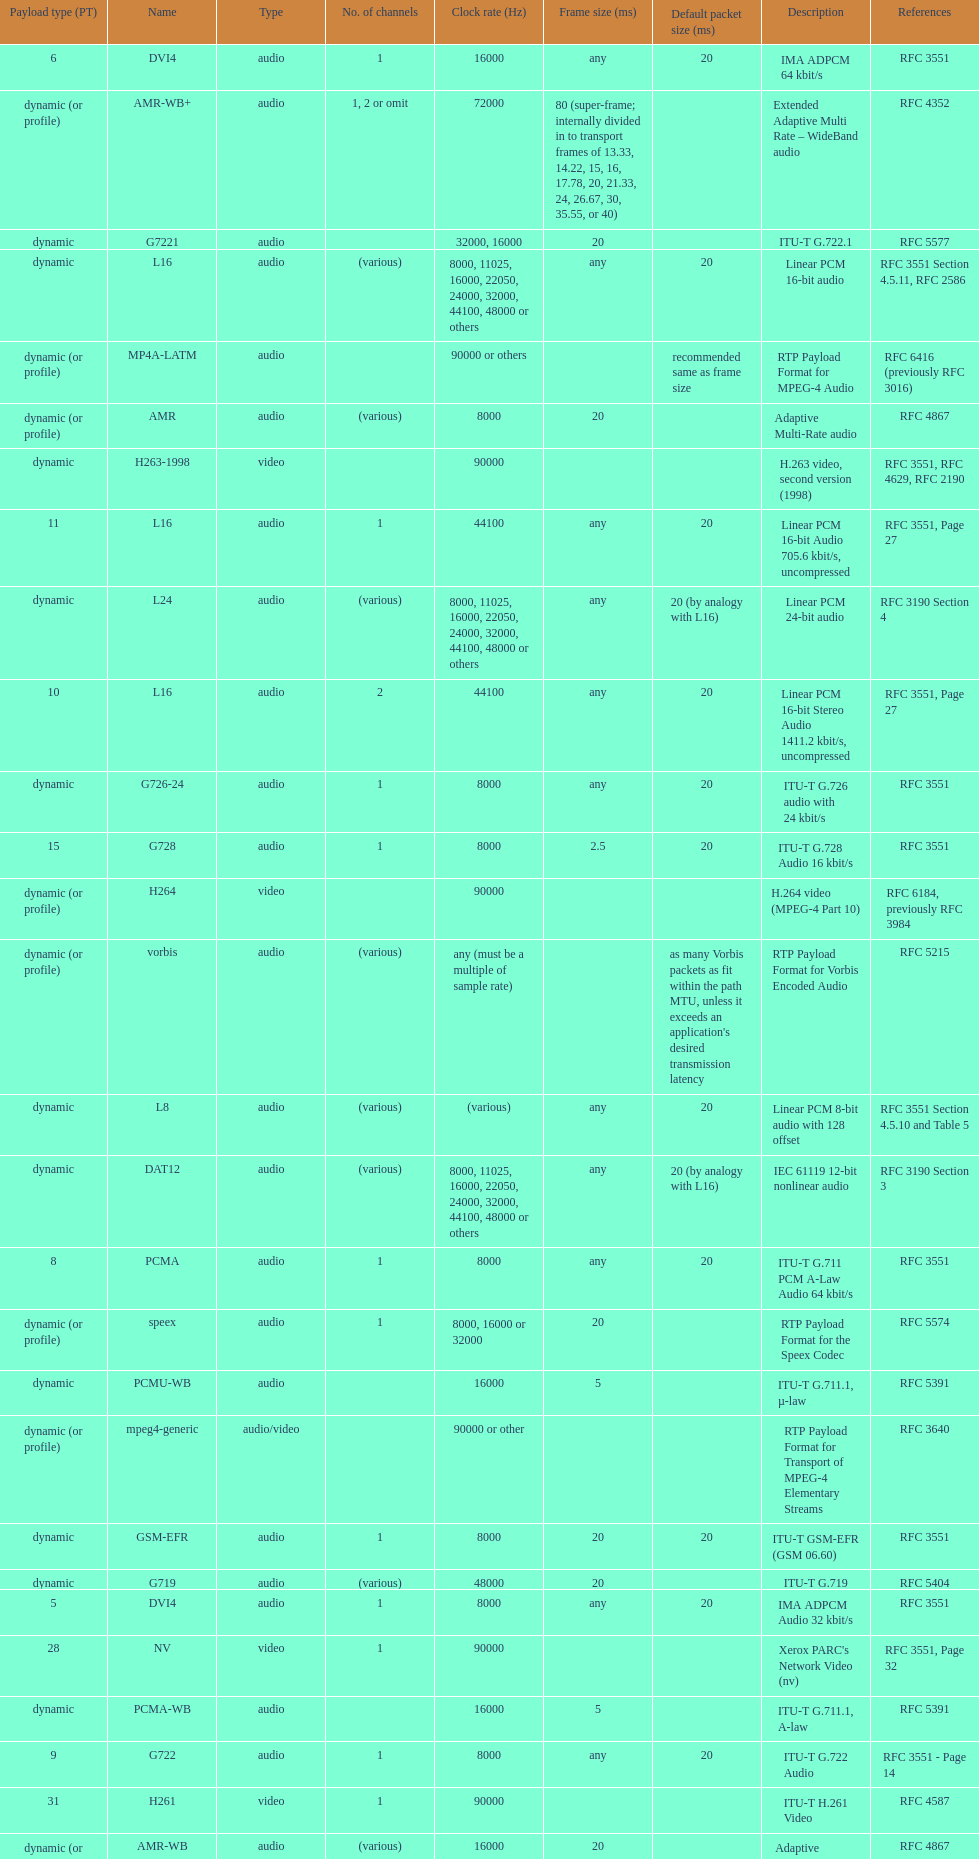What is the average number of channels? 1. 